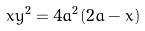<formula> <loc_0><loc_0><loc_500><loc_500>x y ^ { 2 } = 4 a ^ { 2 } ( 2 a - x )</formula> 